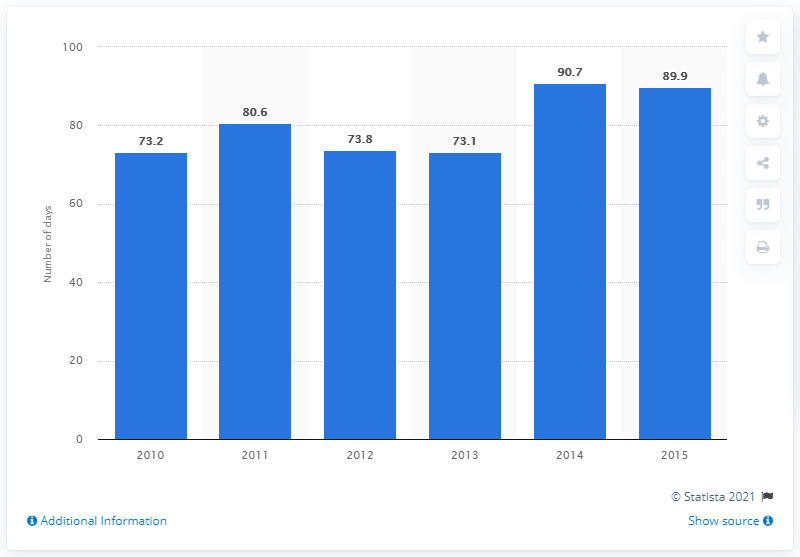Mention a couple of crucial points in this snapshot. In 2014 and 2015, the average number of days was the highest among those two years. The number of days below the average for the past 3 years is less than the average. 